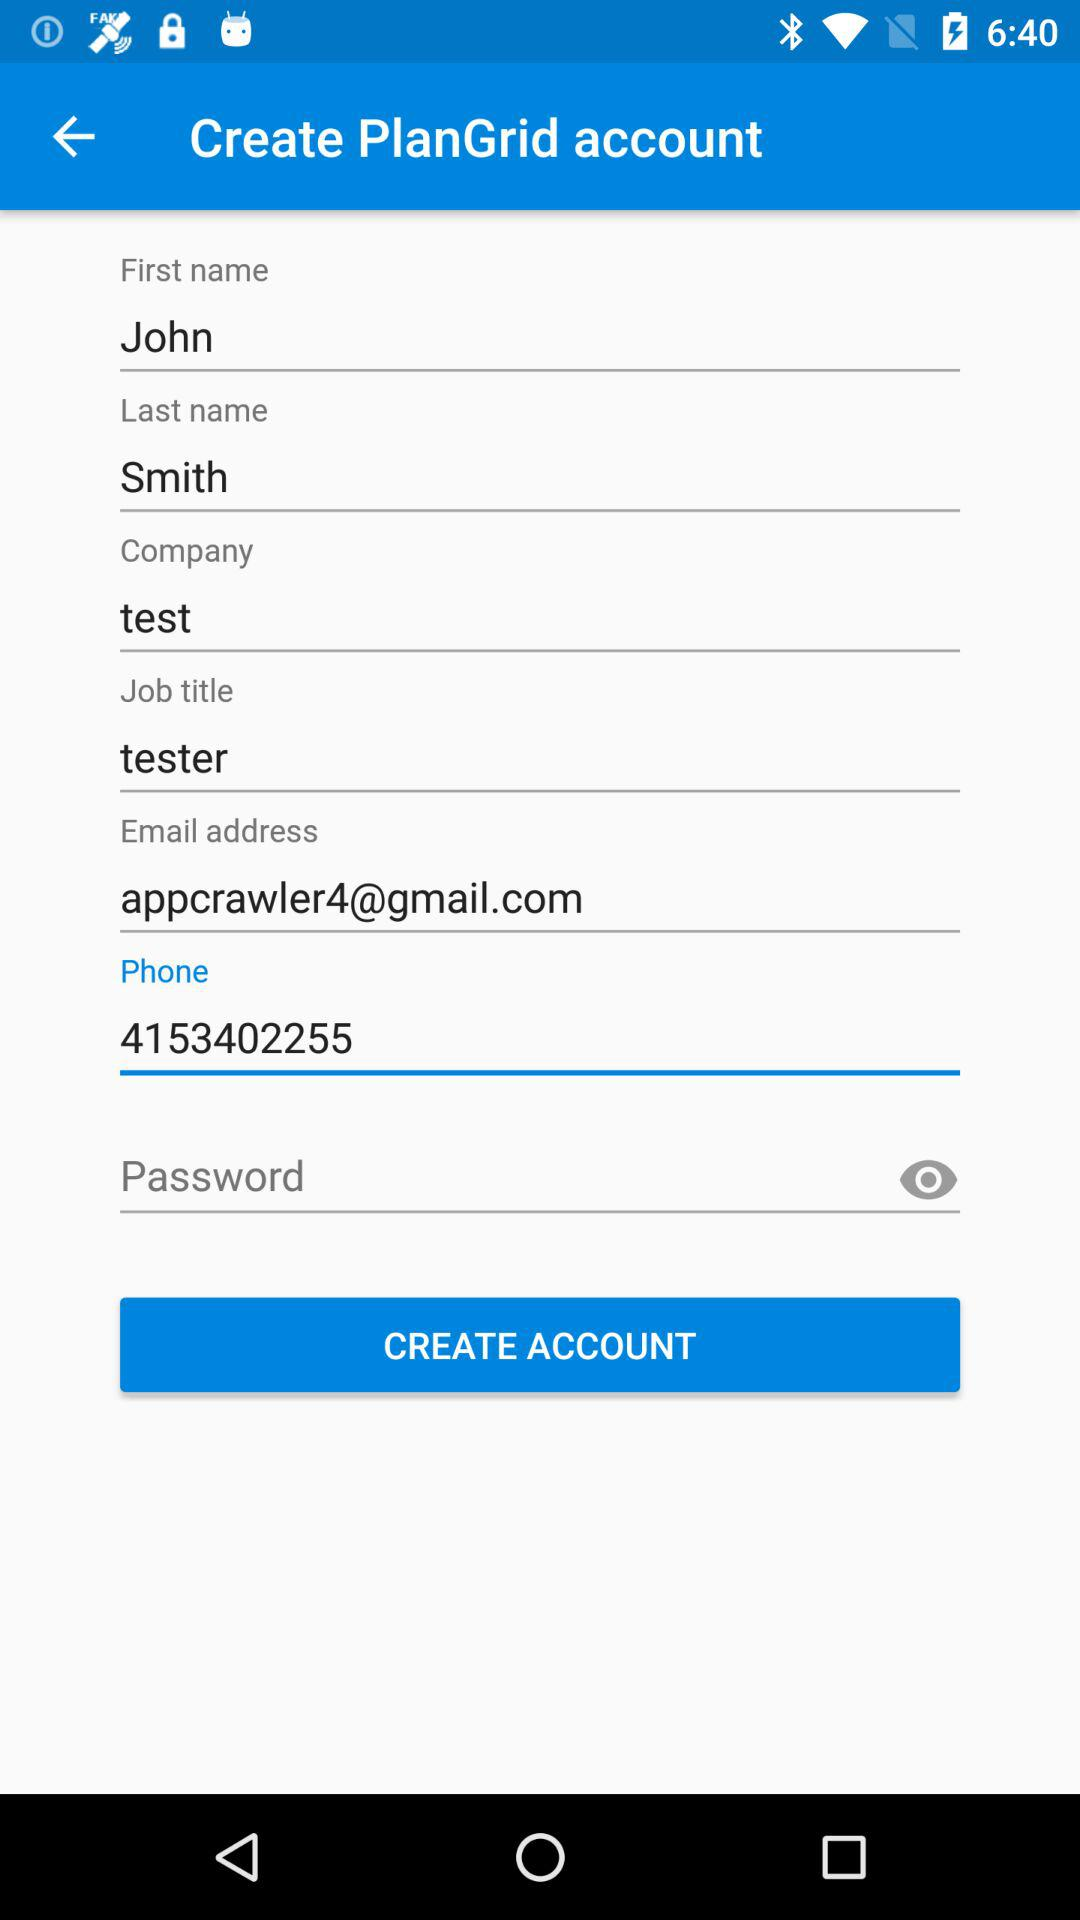What is the name of the user? The name of the user is John Smith. 